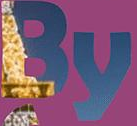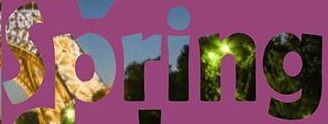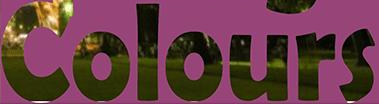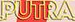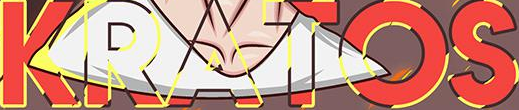Read the text from these images in sequence, separated by a semicolon. By; Spring; Colours; PUTRA; KRATOS 